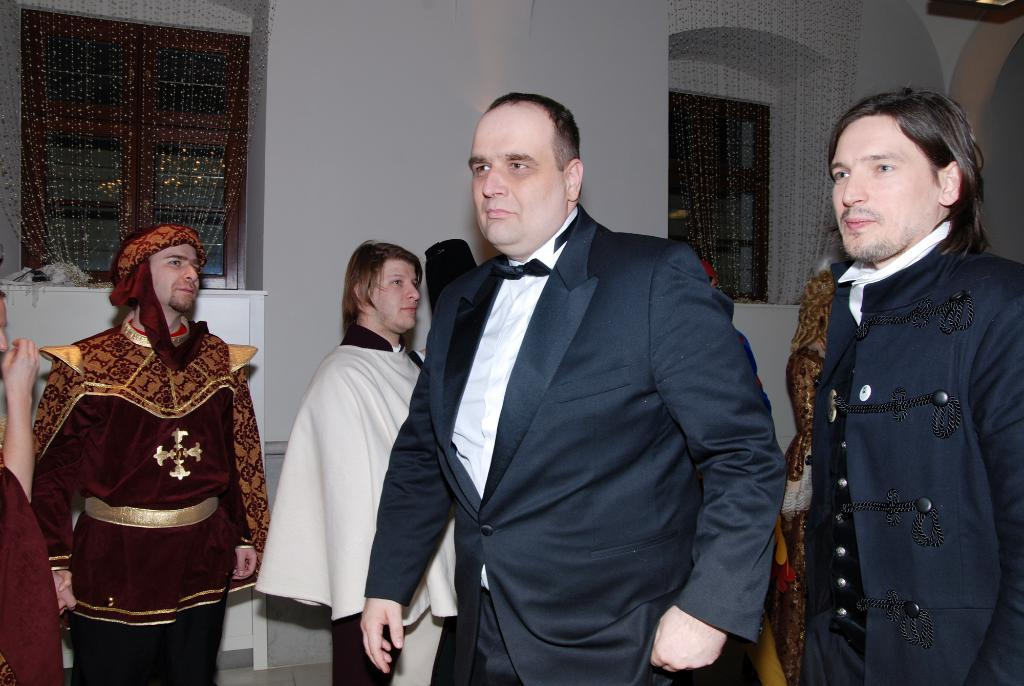What is happening in the image? There are people standing in the image. Can you describe the clothing of one of the individuals? A man in the front is wearing a suit. What can be seen in the background of the image? There is a wall and two windows in the background of the image. How many buttons are on the friend's shirt in the image? There is no friend or shirt with buttons present in the image. What type of line is visible in the image? There is no line visible in the image. 